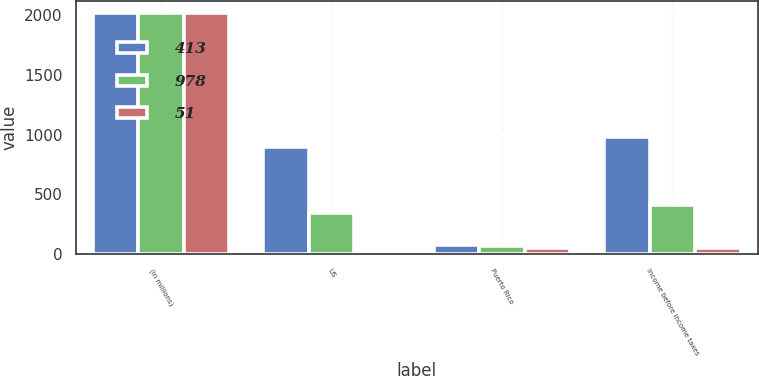<chart> <loc_0><loc_0><loc_500><loc_500><stacked_bar_chart><ecel><fcel>(in millions)<fcel>US<fcel>Puerto Rico<fcel>Income before income taxes<nl><fcel>413<fcel>2015<fcel>898<fcel>80<fcel>978<nl><fcel>978<fcel>2014<fcel>347<fcel>66<fcel>413<nl><fcel>51<fcel>2013<fcel>5<fcel>56<fcel>51<nl></chart> 